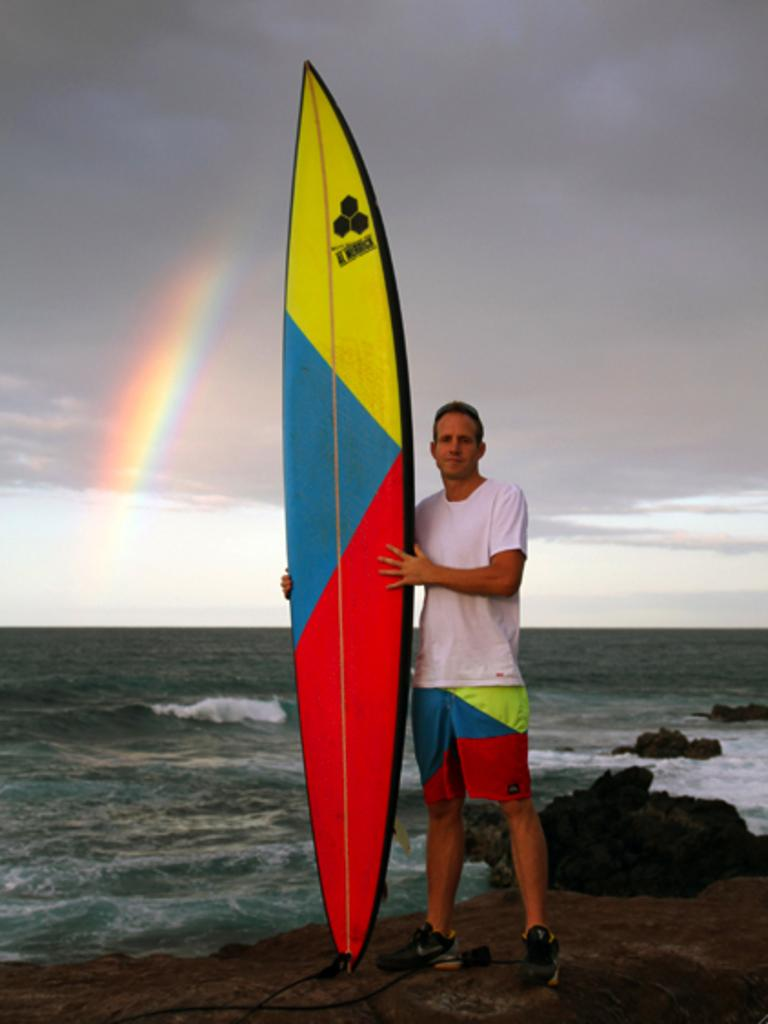What is the main subject of the image? There is a man in the image. What is the man wearing? The man is wearing a white t-shirt and shorts. What is the man holding in the image? The man is holding a surfing board. What type of environment is visible in the image? There is sea water and the sky visible in the image. What additional feature can be seen in the sky? There is a rainbow in the sky. What type of boundary can be seen between the man's elbow and the surfing board? There is no boundary visible between the man's elbow and the surfing board in the image. What type of addition is the man making to the surfing board in the image? The man is not making any addition to the surfing board in the image; he is simply holding it. 